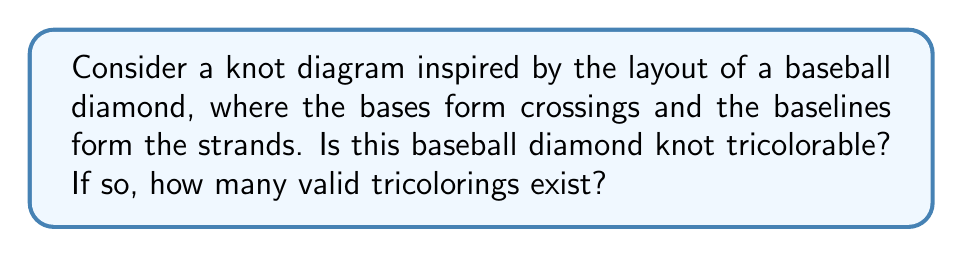What is the answer to this math problem? Let's approach this step-by-step:

1) First, we need to visualize the baseball diamond as a knot diagram:
   [asy]
   unitsize(1cm);
   draw((0,0)--(2,2)--(4,0)--(2,-2)--cycle);
   draw((2,2.2)--(2,1.8));
   draw((4.2,0)--(3.8,0));
   draw((2,-1.8)--(2,-2.2));
   draw((1.8,0)--(2.2,0));
   label("Home", (2,-2.5), S);
   label("1st", (4.5,0), E);
   label("2nd", (2,2.5), N);
   label("3rd", (-.5,0), W);
   [/asy]

2) To determine tricolorability, we need to check if we can color the strands using three colors (let's say Red, Blue, and Green) such that at each crossing, either all three colors are present or only one color is used.

3) Let's start coloring from home plate. We have three choices for this initial strand.

4) Moving clockwise, we reach the first crossing (1st base). Here, we must use a different color for the strand going to 2nd base.

5) At the 2nd base crossing, we must use the third color for the strand going to 3rd base to satisfy the tricoloring condition.

6) Finally, at the 3rd base crossing, we see that we're forced to use the same color as the initial strand from home plate to satisfy the condition.

7) This coloring works and satisfies the tricoloring condition at all crossings.

8) We can generate all valid colorings by rotating the colors in this solution. There are 3 ways to choose the initial color, and once that's chosen, the rest of the coloring is forced.

Therefore, this baseball diamond knot is indeed tricolorable, and there are 3 valid tricolorings.
Answer: Yes, 3 valid tricolorings 